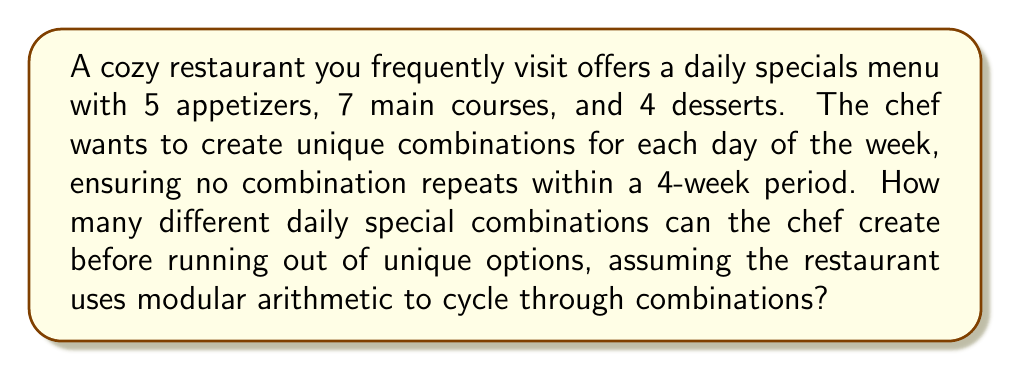Can you solve this math problem? Let's approach this step-by-step:

1) First, we need to calculate the total number of possible combinations:
   $$ \text{Total combinations} = 5 \times 7 \times 4 = 140 $$

2) The restaurant needs unique combinations for each day of the week for 4 weeks:
   $$ \text{Days needed} = 7 \times 4 = 28 $$

3) To find how many unique combinations the chef can create before repeating, we use the modulo operation. The number of unique combinations will be:
   $$ \text{Unique combinations} \equiv 140 \pmod{28} $$

4) To solve this, we divide 140 by 28:
   $$ 140 = 28 \times 5 + 0 $$

5) The remainder is 0, which means that 140 is divisible by 28. Therefore, the chef can create exactly 140 unique combinations before needing to repeat.

6) This also means that the chef can create unique combinations for:
   $$ \frac{140}{7} = 20 \text{ weeks} $$
   before needing to repeat any combination.
Answer: 140 unique combinations 